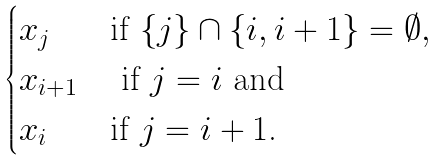Convert formula to latex. <formula><loc_0><loc_0><loc_500><loc_500>\begin{cases} x _ { j } & \text {if $\{j\} \cap \{i,i+1\} = \emptyset$} , \\ x _ { i + 1 } & \text { if $j = i$ and} \\ x _ { i } & \text {if $j = i+1$.} \end{cases}</formula> 